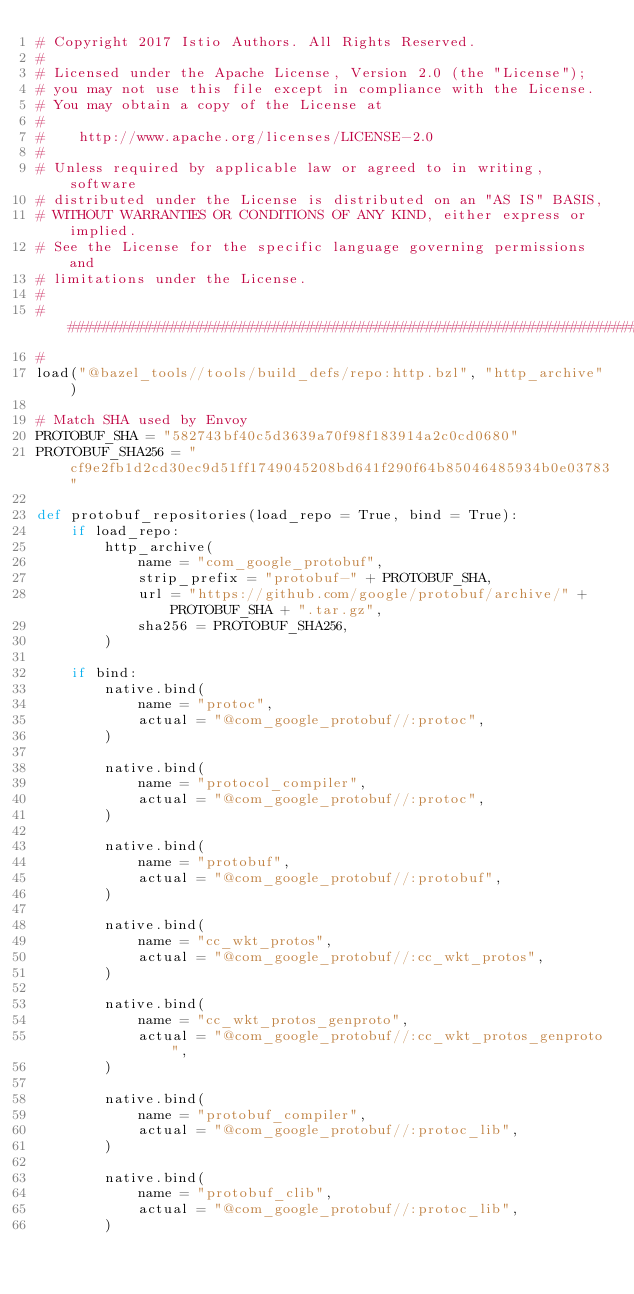Convert code to text. <code><loc_0><loc_0><loc_500><loc_500><_Python_># Copyright 2017 Istio Authors. All Rights Reserved.
#
# Licensed under the Apache License, Version 2.0 (the "License");
# you may not use this file except in compliance with the License.
# You may obtain a copy of the License at
#
#    http://www.apache.org/licenses/LICENSE-2.0
#
# Unless required by applicable law or agreed to in writing, software
# distributed under the License is distributed on an "AS IS" BASIS,
# WITHOUT WARRANTIES OR CONDITIONS OF ANY KIND, either express or implied.
# See the License for the specific language governing permissions and
# limitations under the License.
#
################################################################################
#
load("@bazel_tools//tools/build_defs/repo:http.bzl", "http_archive")

# Match SHA used by Envoy
PROTOBUF_SHA = "582743bf40c5d3639a70f98f183914a2c0cd0680"
PROTOBUF_SHA256 = "cf9e2fb1d2cd30ec9d51ff1749045208bd641f290f64b85046485934b0e03783"

def protobuf_repositories(load_repo = True, bind = True):
    if load_repo:
        http_archive(
            name = "com_google_protobuf",
            strip_prefix = "protobuf-" + PROTOBUF_SHA,
            url = "https://github.com/google/protobuf/archive/" + PROTOBUF_SHA + ".tar.gz",
            sha256 = PROTOBUF_SHA256,
        )

    if bind:
        native.bind(
            name = "protoc",
            actual = "@com_google_protobuf//:protoc",
        )

        native.bind(
            name = "protocol_compiler",
            actual = "@com_google_protobuf//:protoc",
        )

        native.bind(
            name = "protobuf",
            actual = "@com_google_protobuf//:protobuf",
        )

        native.bind(
            name = "cc_wkt_protos",
            actual = "@com_google_protobuf//:cc_wkt_protos",
        )

        native.bind(
            name = "cc_wkt_protos_genproto",
            actual = "@com_google_protobuf//:cc_wkt_protos_genproto",
        )

        native.bind(
            name = "protobuf_compiler",
            actual = "@com_google_protobuf//:protoc_lib",
        )

        native.bind(
            name = "protobuf_clib",
            actual = "@com_google_protobuf//:protoc_lib",
        )
</code> 